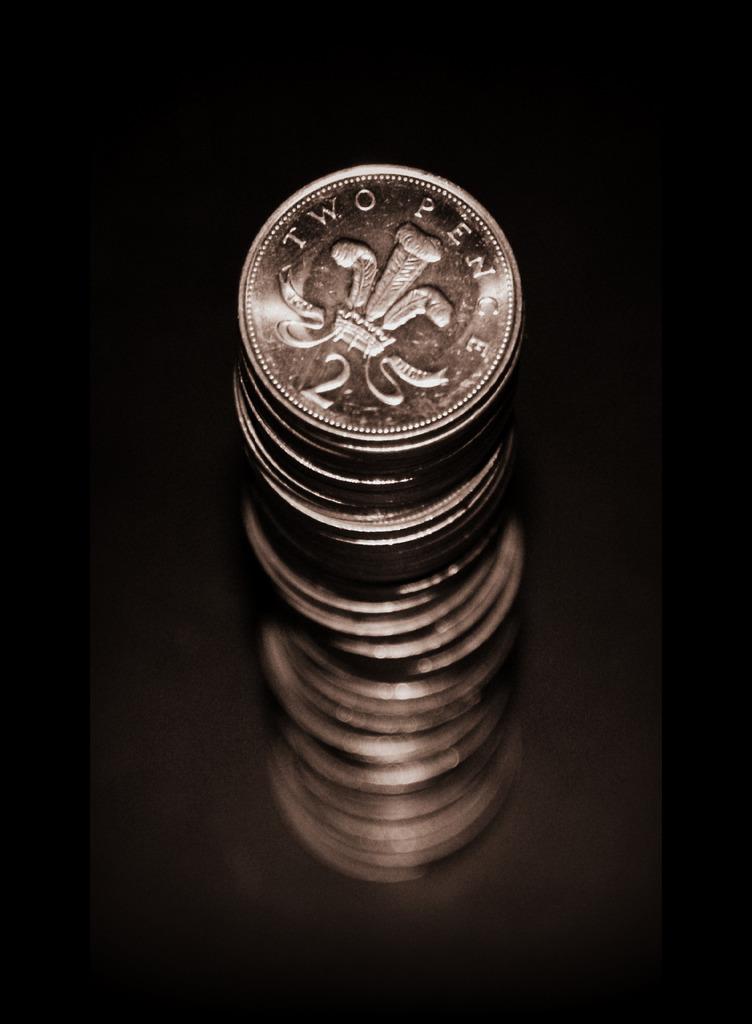How much is the coin worth?
Provide a succinct answer. Two pence. What number is on the coin?
Ensure brevity in your answer.  2. 